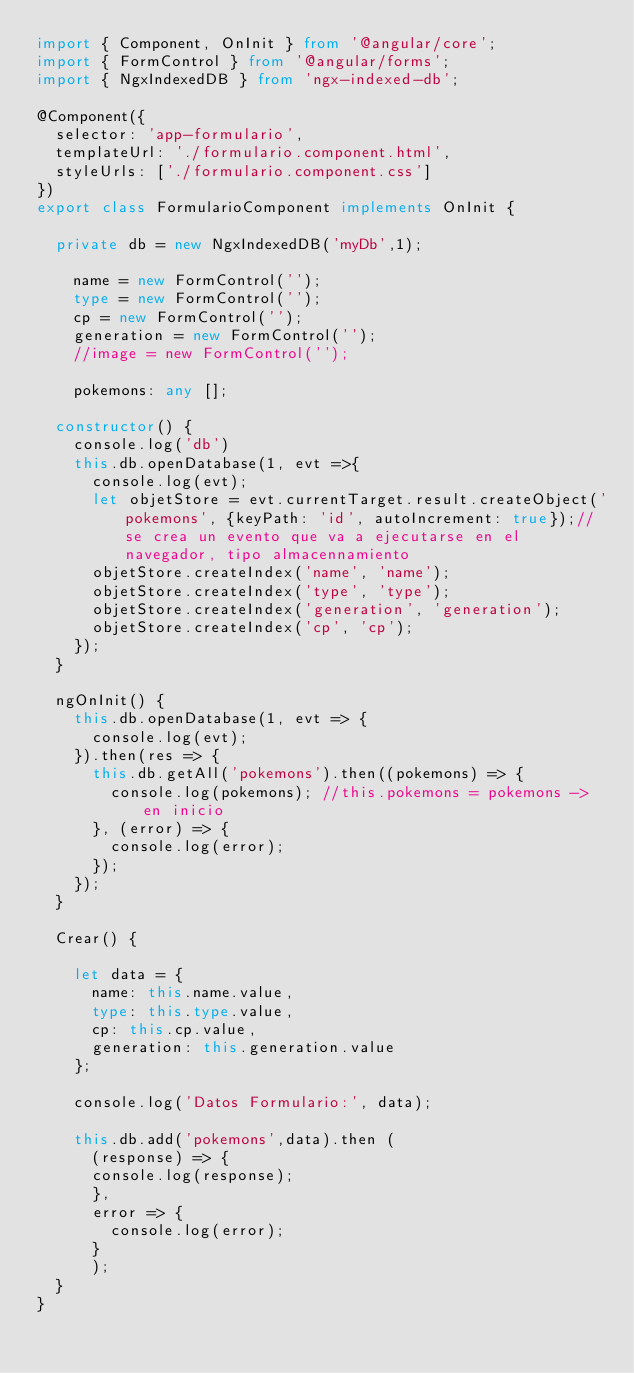Convert code to text. <code><loc_0><loc_0><loc_500><loc_500><_TypeScript_>import { Component, OnInit } from '@angular/core';
import { FormControl } from '@angular/forms';
import { NgxIndexedDB } from 'ngx-indexed-db';

@Component({
  selector: 'app-formulario',
  templateUrl: './formulario.component.html',
  styleUrls: ['./formulario.component.css']
})
export class FormularioComponent implements OnInit {

  private db = new NgxIndexedDB('myDb',1); 

    name = new FormControl('');
    type = new FormControl('');
    cp = new FormControl('');
    generation = new FormControl('');
    //image = new FormControl('');

    pokemons: any [];

  constructor() { 
    console.log('db')
    this.db.openDatabase(1, evt =>{
      console.log(evt);
      let objetStore = evt.currentTarget.result.createObject('pokemons', {keyPath: 'id', autoIncrement: true});//se crea un evento que va a ejecutarse en el navegador, tipo almacennamiento
      objetStore.createIndex('name', 'name');
      objetStore.createIndex('type', 'type');
      objetStore.createIndex('generation', 'generation');
      objetStore.createIndex('cp', 'cp');
    });
  }

  ngOnInit() {
    this.db.openDatabase(1, evt => {
      console.log(evt);
    }).then(res => {
      this.db.getAll('pokemons').then((pokemons) => {
        console.log(pokemons); //this.pokemons = pokemons -> en inicio
      }, (error) => {
        console.log(error);
      });
    }); 
  }

  Crear() {
    
    let data = {
      name: this.name.value,
      type: this.type.value,
      cp: this.cp.value,
      generation: this.generation.value
    };

    console.log('Datos Formulario:', data);

    this.db.add('pokemons',data).then (
      (response) => {
      console.log(response);
      },
      error => {
        console.log(error);
      }
      );
  }
}
</code> 